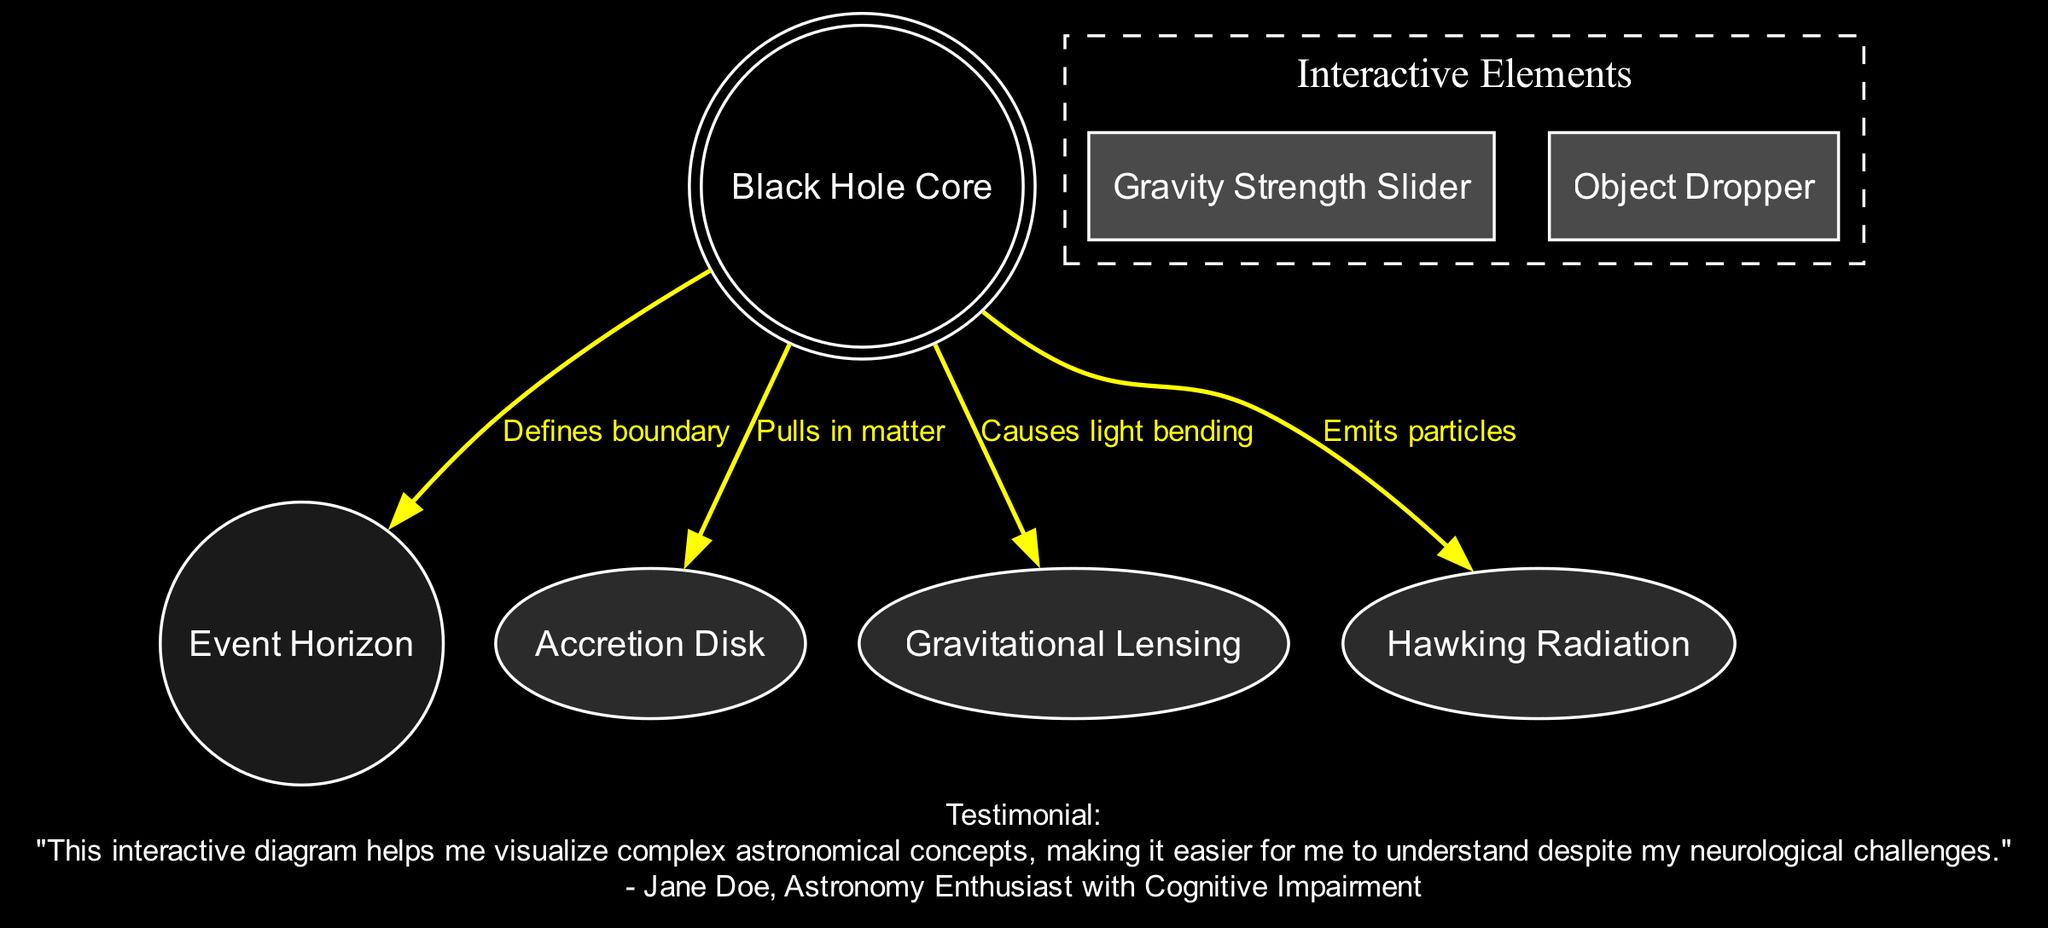What is the label of the central part of the black hole? The central part of the black hole is labeled as "Black Hole Core" according to the diagram provided.
Answer: Black Hole Core How many nodes are present in the diagram? Counting the nodes listed in the data yields a total of five distinct nodes, which are the Black Hole Core, Event Horizon, Accretion Disk, Gravitational Lensing, and Hawking Radiation.
Answer: 5 What defines the boundary of a black hole? The diagram indicates that the Event Horizon defines the boundary between the black hole and the surrounding region where escape is still possible.
Answer: Event Horizon What effect does the black hole have on nearby light? According to the diagram, the black hole causes light bending, which corresponds to the phenomenon known as Gravitational Lensing.
Answer: Gravitational Lensing What theoretical emission is associated with black holes as per the diagram? The diagram mentions Hawking Radiation, which is the theoretical emission of particles from black holes, as an associated phenomenon.
Answer: Hawking Radiation How does the black hole interact with the accretion disk? The black hole pulls in matter from the Accretion Disk, as indicated by the direct connection between these two nodes in the diagram.
Answer: Pulls in matter If the gravity strength is adjusted, what can be observed? Adjusting the gravity strength via the Gravity Strength Slider will allow the user to see effects on nearby objects, demonstrating how varying gravitational forces affect them.
Answer: Effects on nearby objects What is the function of the Object Dropper? The Object Dropper allows users to place objects near the black hole to observe the corresponding gravitational interactions, as indicated in the interactive elements of the diagram.
Answer: Observe gravitational effects What connects the black hole core to Hawking radiation in the diagram? The connection between the black hole core and Hawking Radiation is defined by the labeled edge stating that the black hole emits particles.
Answer: Emits particles 